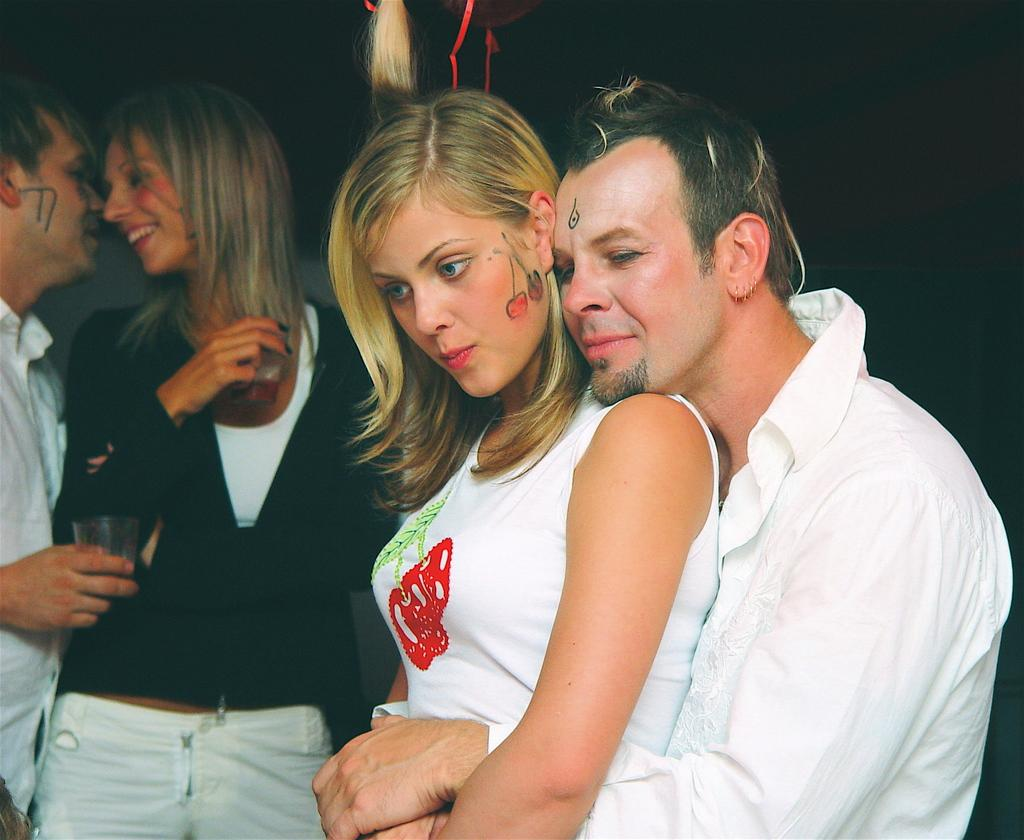What is happening in the image? There are people standing in the image. Can you describe the attire of the people? The people are wearing different color dresses. What are two people doing in the background? Two people are holding glasses in the background. How would you describe the lighting in the image? The background is dark. What type of feast is being celebrated in the image? There is no feast present in the image; it simply shows people standing and holding glasses. Can you tell me which band is performing in the image? There is no band performing in the image. 